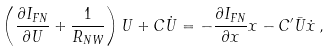<formula> <loc_0><loc_0><loc_500><loc_500>\left ( \frac { \partial I _ { F N } } { \partial U } + \frac { 1 } { R _ { N W } } \right ) U + C \dot { U } = - \frac { \partial I _ { F N } } { \partial x } x - C ^ { \prime } \bar { U } \dot { x } \, ,</formula> 